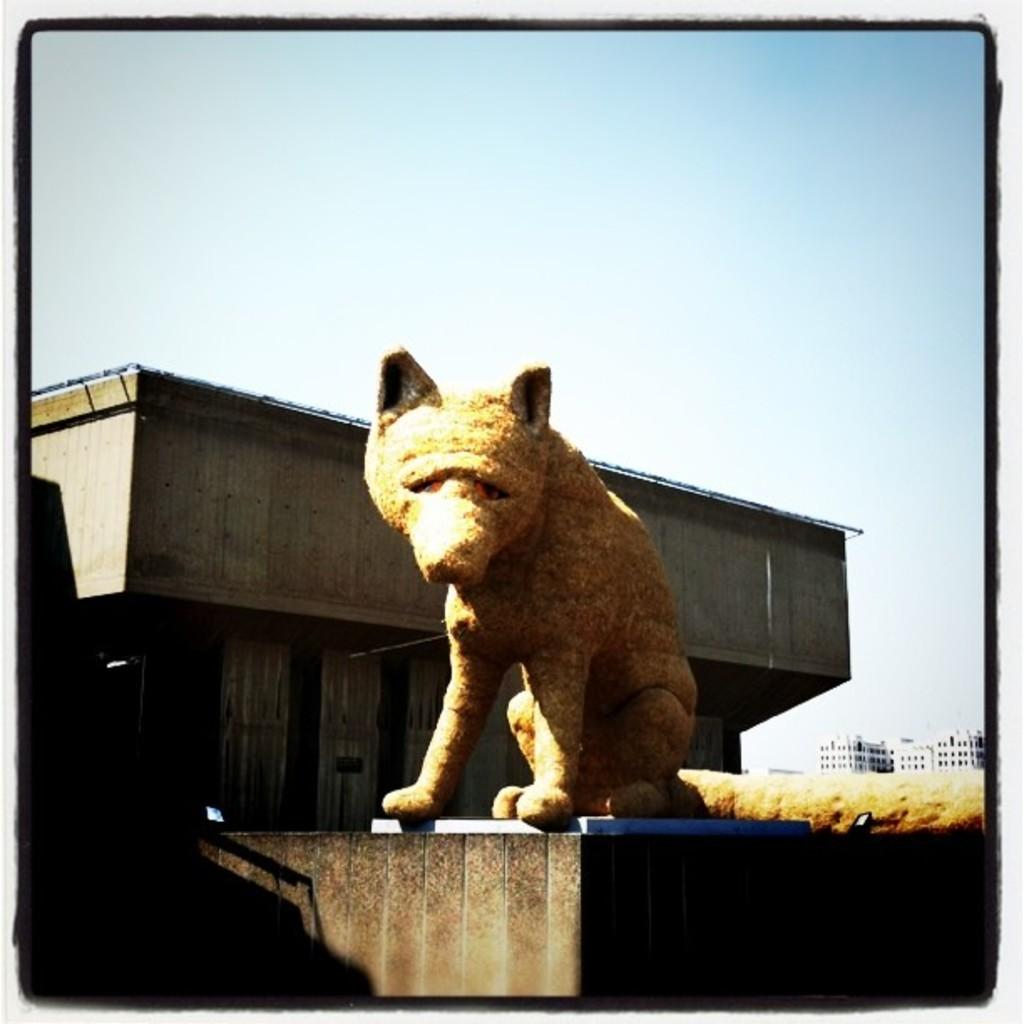What is the main subject of the image? There is a sculpture of an animal in the image. Where is the sculpture located? The sculpture is on a building. What can be seen in the background of the image? The sky and other buildings are visible in the background of the image. Can you tell me how many pans are being held by the person in the image? There is no person present in the image, and therefore no pans are being held. What type of hand is shown interacting with the sculpture in the image? There is no hand shown interacting with the sculpture in the image; it is a static sculpture on a building. 